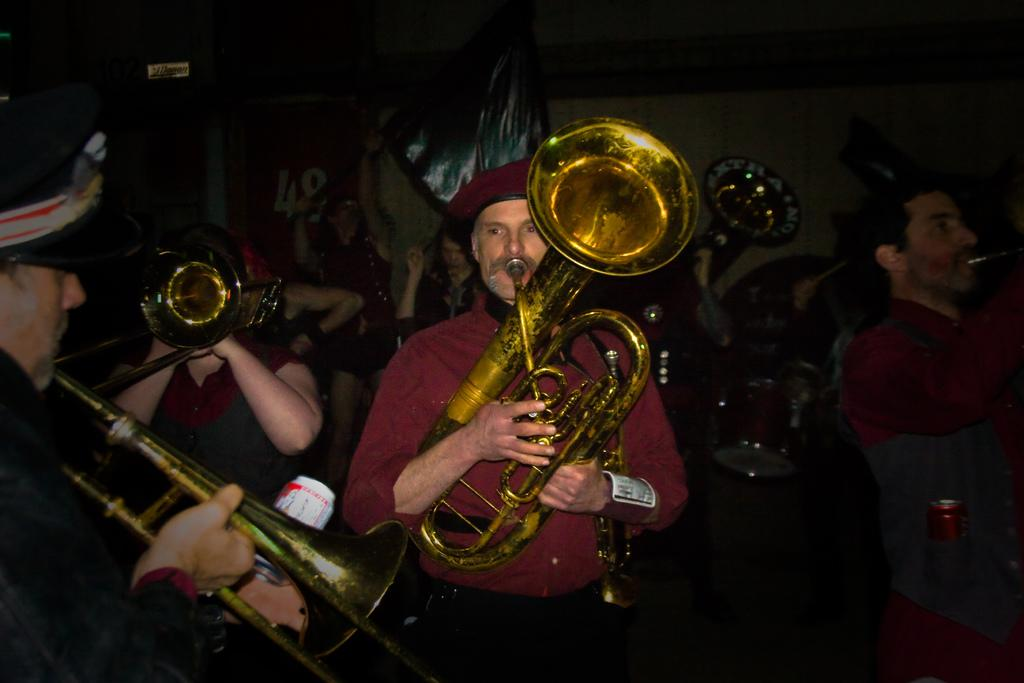What are the people in the image doing? The people in the image are playing trumpets. Can you describe the woman in the image? The woman in the image is holding a flag. What is the interest rate on the woman's debt in the image? There is no information about the woman's debt or interest rate in the image. Can you tell me how many wrenches the people playing trumpets are holding? There are no wrenches visible in the image; the people are playing trumpets. 